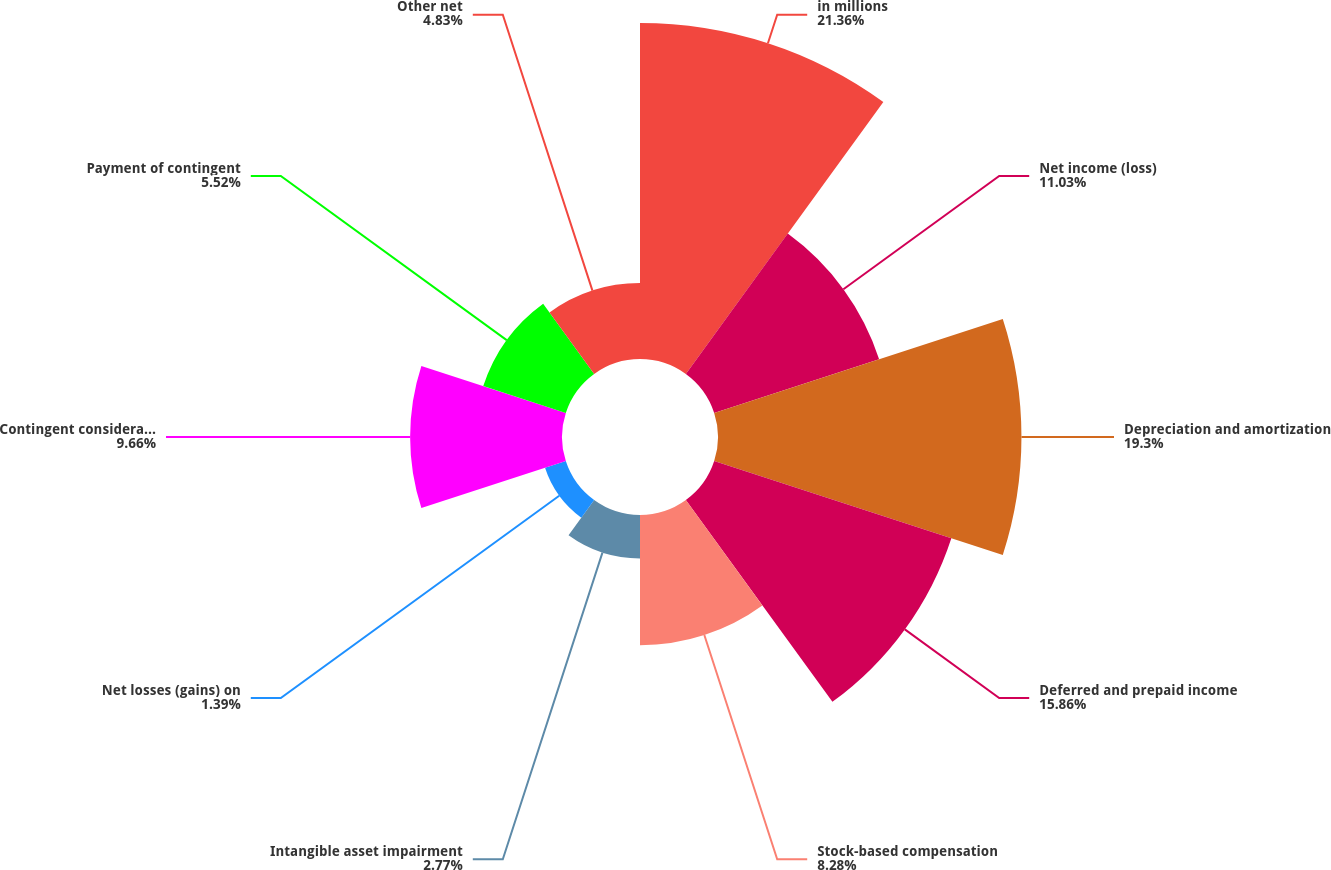Convert chart. <chart><loc_0><loc_0><loc_500><loc_500><pie_chart><fcel>in millions<fcel>Net income (loss)<fcel>Depreciation and amortization<fcel>Deferred and prepaid income<fcel>Stock-based compensation<fcel>Intangible asset impairment<fcel>Net losses (gains) on<fcel>Contingent consideration<fcel>Payment of contingent<fcel>Other net<nl><fcel>21.37%<fcel>11.03%<fcel>19.3%<fcel>15.86%<fcel>8.28%<fcel>2.77%<fcel>1.39%<fcel>9.66%<fcel>5.52%<fcel>4.83%<nl></chart> 